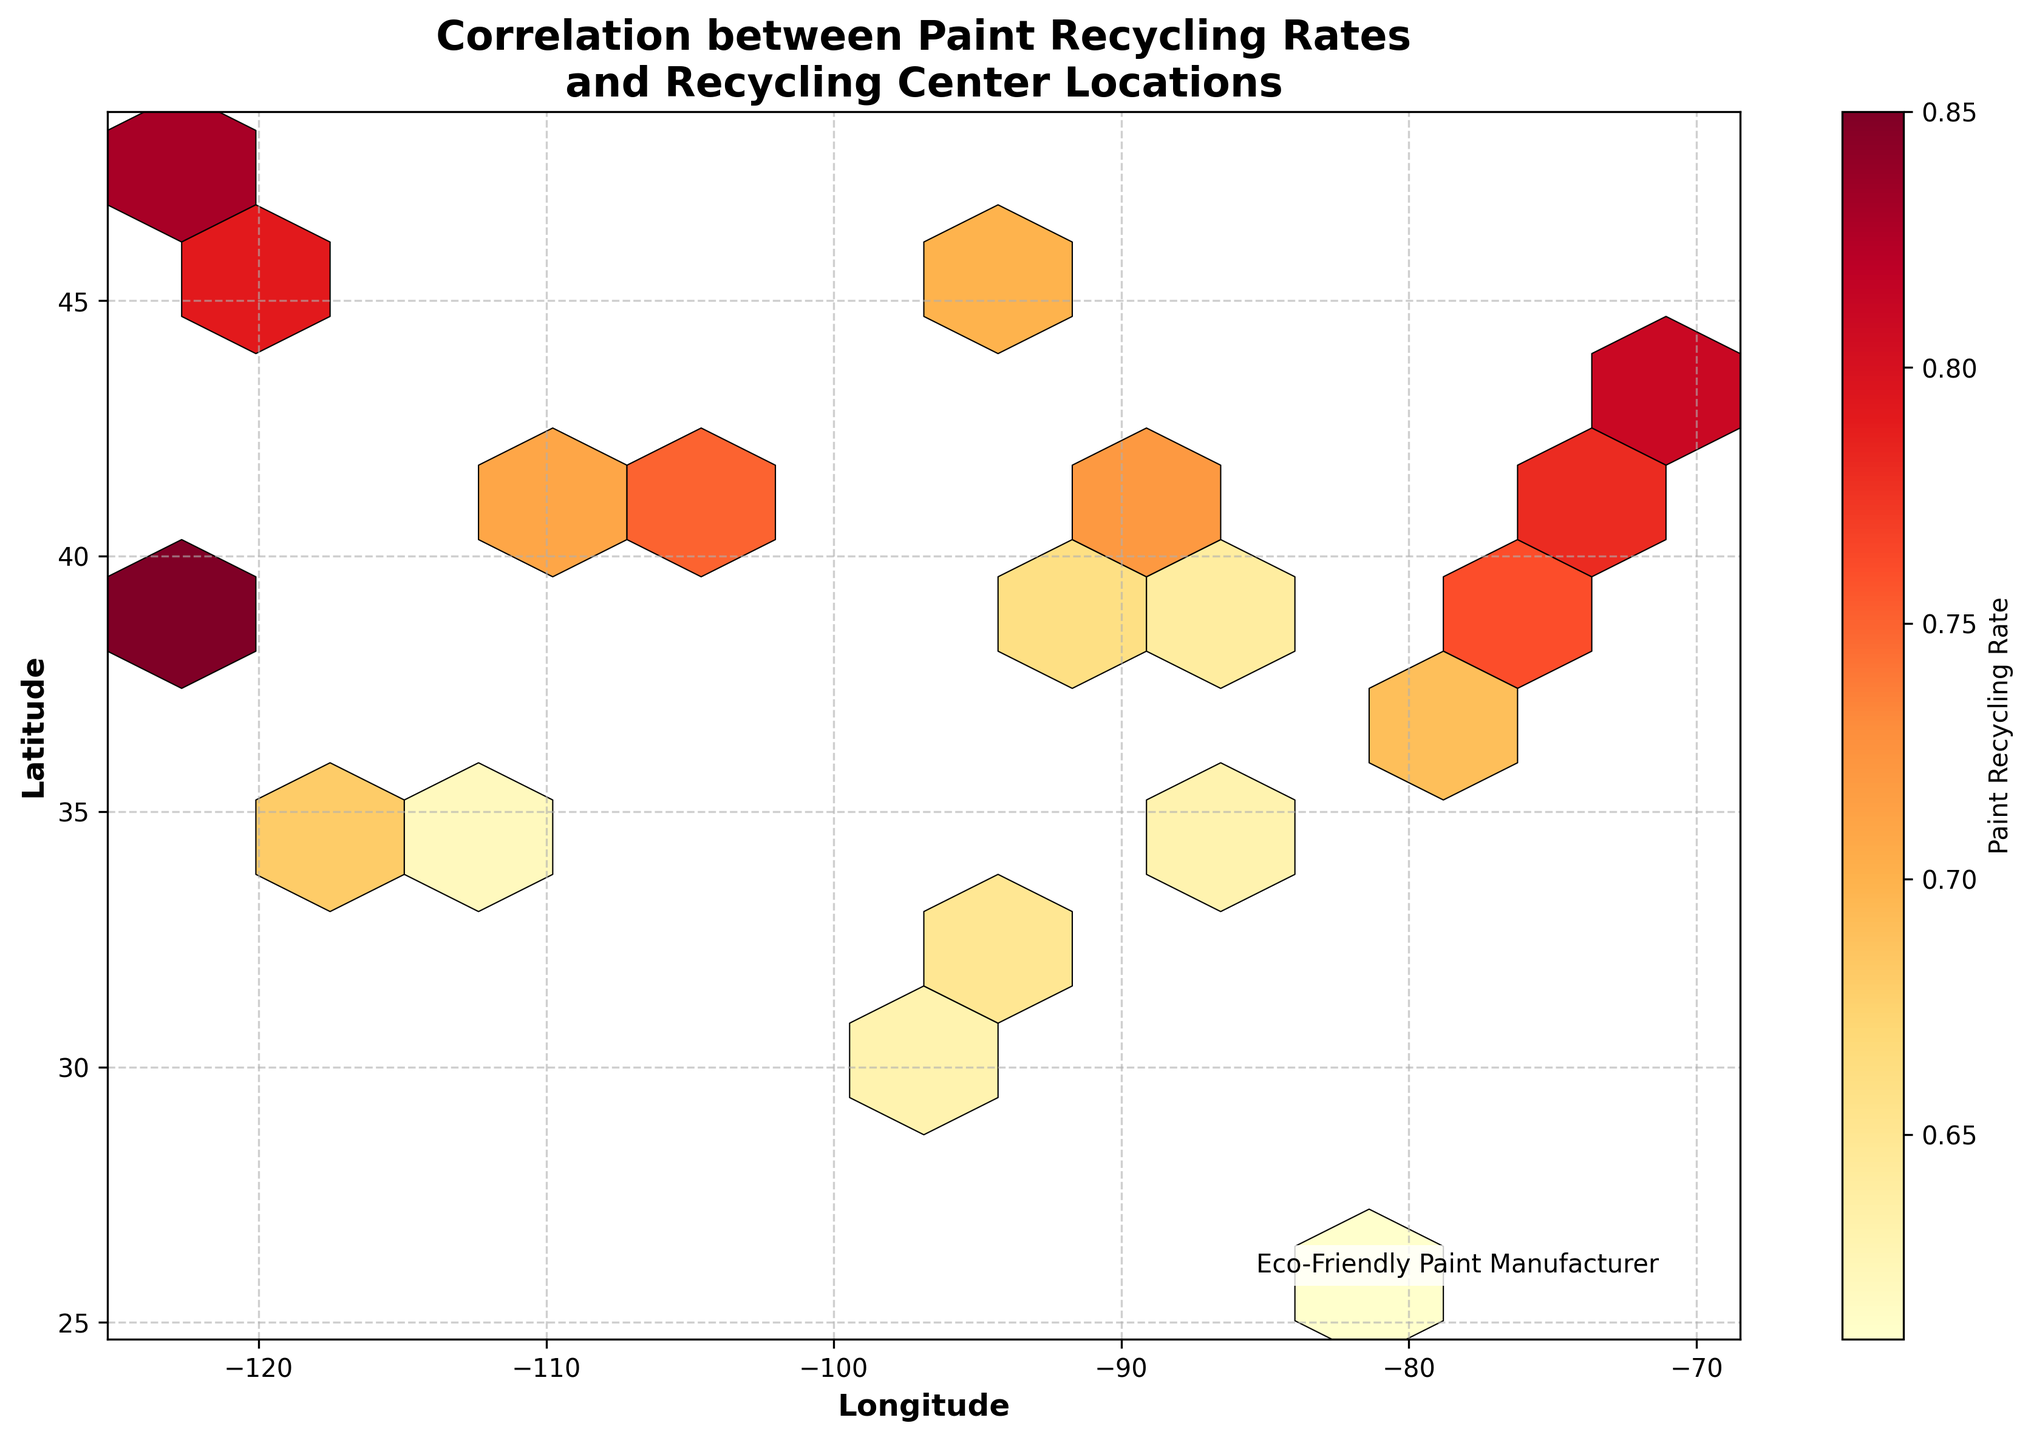What is the title of the hexbin plot? The title of the hexbin plot is displayed at the top of the figure.
Answer: Correlation between Paint Recycling Rates and Recycling Center Locations What do the color gradations in the hexbin plot represent? In a hexbin plot, colors represent different ranges of values. This plot uses a gradient from 'YlOrRd' colormap indicating the paint recycling rates. Darker colors (red) represent higher recycling rates, while lighter colors (yellow) indicate lower rates.
Answer: Paint Recycling Rate How many data points are represented in the hexbin plot? The hexbin plot represents the aggregation of the underlying data points into hexagonal bins. Each hexagon contains one or more data points. The precise number can be counted from the input data but is also implied by hexagonal distributions.
Answer: 20 data points Which location has the highest paint recycling rate? By analyzing the color intensity of hexagons and referring to the input data, the highest rate corresponds to the darkest red hexagon.
Answer: San Francisco (-122.4194, 37.7749) Are there more recycling centers with high rates in the eastern or western United States? High recycling rates are indicated by darker colors. Count the number of darker hexagons in both eastern and western regions of the plot.
Answer: Western United States What is the longitude and latitude range covered in this hexbin plot? The hexbin plot axes typically indicate the range of longitude and latitude values covered by the data.
Answer: Longitude: -122.6784 to -71.0589, Latitude: 25.7617 to 47.6062 Find the city with the lowest paint recycling rate and its geographical location. By identifying the lightest colored hexagon from the plot and matching it to the input data.
Answer: Houston (-95.3698, 29.7604), Rate: 0.59 How does the recycling rate in New York compare to that in Los Angeles? Check the hexbin color shades for New York (-74.0060, 40.7128) and Los Angeles (-118.2437, 34.0522), compare their values from the input data.
Answer: Higher in New York (0.78) than in Los Angeles (0.68) Review the correlation between latitude and paint recycling rate. Are higher latitudes generally associated with higher recycling rates? Observe the color gradient across latitude. Higher latitudes should display darker colors if there's positive correlation.
Answer: Generally, yes What is the median paint recycling rate of all the represented locations? Sort the recycling rates and find the middle value. The sorted rates are [0.59, 0.61, 0.62, 0.63, 0.64, 0.65, 0.66, 0.67, 0.68, 0.69, 0.70, 0.71, 0.72, 0.75, 0.76, 0.78, 0.79, 0.81, 0.83, 0.85]. Median value is (0.69 + 0.70)/2 = 0.695.
Answer: 0.695 